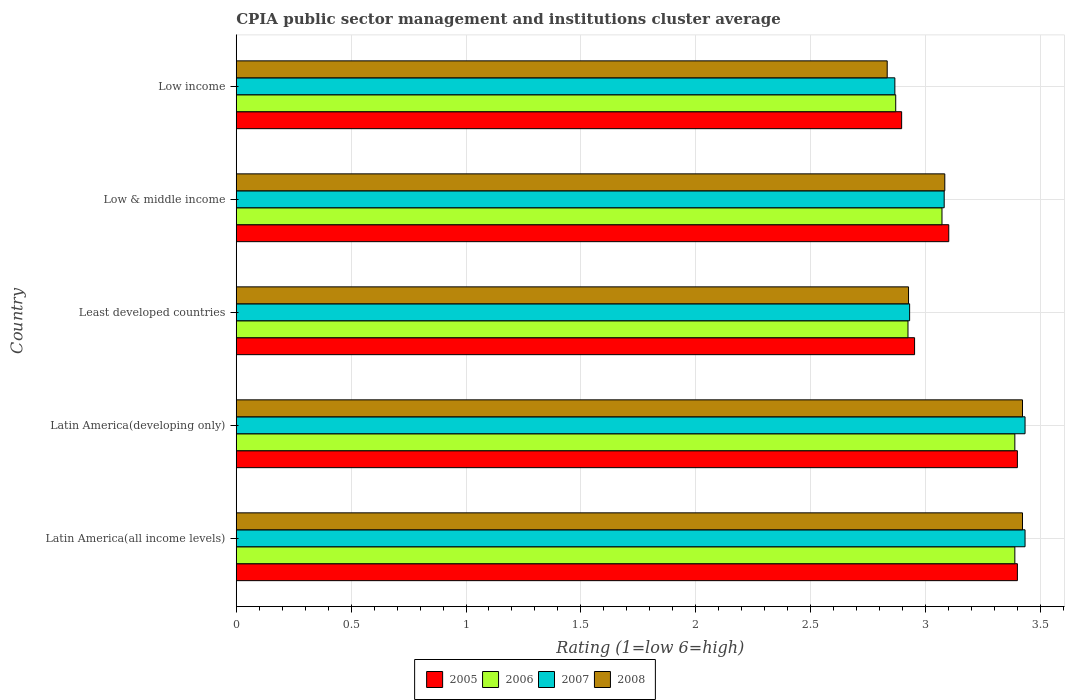How many groups of bars are there?
Offer a terse response. 5. Are the number of bars per tick equal to the number of legend labels?
Make the answer very short. Yes. How many bars are there on the 5th tick from the top?
Provide a succinct answer. 4. How many bars are there on the 5th tick from the bottom?
Offer a very short reply. 4. What is the label of the 1st group of bars from the top?
Offer a terse response. Low income. What is the CPIA rating in 2006 in Latin America(developing only)?
Provide a succinct answer. 3.39. Across all countries, what is the maximum CPIA rating in 2007?
Give a very brief answer. 3.43. Across all countries, what is the minimum CPIA rating in 2007?
Make the answer very short. 2.87. In which country was the CPIA rating in 2006 maximum?
Your response must be concise. Latin America(all income levels). What is the total CPIA rating in 2005 in the graph?
Give a very brief answer. 15.75. What is the difference between the CPIA rating in 2008 in Least developed countries and that in Low & middle income?
Your answer should be very brief. -0.16. What is the difference between the CPIA rating in 2006 in Latin America(all income levels) and the CPIA rating in 2005 in Low income?
Keep it short and to the point. 0.49. What is the average CPIA rating in 2006 per country?
Make the answer very short. 3.13. What is the difference between the CPIA rating in 2007 and CPIA rating in 2005 in Latin America(developing only)?
Provide a succinct answer. 0.03. In how many countries, is the CPIA rating in 2005 greater than 0.2 ?
Keep it short and to the point. 5. What is the ratio of the CPIA rating in 2006 in Latin America(developing only) to that in Least developed countries?
Provide a short and direct response. 1.16. Is the CPIA rating in 2005 in Latin America(all income levels) less than that in Latin America(developing only)?
Keep it short and to the point. No. Is the difference between the CPIA rating in 2007 in Latin America(developing only) and Low & middle income greater than the difference between the CPIA rating in 2005 in Latin America(developing only) and Low & middle income?
Offer a very short reply. Yes. What is the difference between the highest and the second highest CPIA rating in 2005?
Your response must be concise. 0. What is the difference between the highest and the lowest CPIA rating in 2006?
Provide a succinct answer. 0.52. In how many countries, is the CPIA rating in 2005 greater than the average CPIA rating in 2005 taken over all countries?
Provide a succinct answer. 2. Is it the case that in every country, the sum of the CPIA rating in 2006 and CPIA rating in 2008 is greater than the sum of CPIA rating in 2005 and CPIA rating in 2007?
Your answer should be very brief. No. Is it the case that in every country, the sum of the CPIA rating in 2008 and CPIA rating in 2006 is greater than the CPIA rating in 2005?
Provide a short and direct response. Yes. How many bars are there?
Offer a very short reply. 20. How many countries are there in the graph?
Your response must be concise. 5. What is the difference between two consecutive major ticks on the X-axis?
Your answer should be compact. 0.5. Are the values on the major ticks of X-axis written in scientific E-notation?
Ensure brevity in your answer.  No. Does the graph contain any zero values?
Offer a very short reply. No. Does the graph contain grids?
Your answer should be very brief. Yes. How are the legend labels stacked?
Your answer should be very brief. Horizontal. What is the title of the graph?
Your answer should be very brief. CPIA public sector management and institutions cluster average. Does "1965" appear as one of the legend labels in the graph?
Your answer should be compact. No. What is the label or title of the X-axis?
Your answer should be compact. Rating (1=low 6=high). What is the Rating (1=low 6=high) in 2006 in Latin America(all income levels)?
Provide a short and direct response. 3.39. What is the Rating (1=low 6=high) of 2007 in Latin America(all income levels)?
Your answer should be very brief. 3.43. What is the Rating (1=low 6=high) of 2008 in Latin America(all income levels)?
Your answer should be very brief. 3.42. What is the Rating (1=low 6=high) of 2005 in Latin America(developing only)?
Your answer should be compact. 3.4. What is the Rating (1=low 6=high) of 2006 in Latin America(developing only)?
Provide a short and direct response. 3.39. What is the Rating (1=low 6=high) of 2007 in Latin America(developing only)?
Offer a terse response. 3.43. What is the Rating (1=low 6=high) in 2008 in Latin America(developing only)?
Your answer should be very brief. 3.42. What is the Rating (1=low 6=high) of 2005 in Least developed countries?
Provide a succinct answer. 2.95. What is the Rating (1=low 6=high) of 2006 in Least developed countries?
Your answer should be compact. 2.92. What is the Rating (1=low 6=high) of 2007 in Least developed countries?
Your answer should be compact. 2.93. What is the Rating (1=low 6=high) of 2008 in Least developed countries?
Offer a terse response. 2.93. What is the Rating (1=low 6=high) of 2005 in Low & middle income?
Give a very brief answer. 3.1. What is the Rating (1=low 6=high) of 2006 in Low & middle income?
Make the answer very short. 3.07. What is the Rating (1=low 6=high) in 2007 in Low & middle income?
Ensure brevity in your answer.  3.08. What is the Rating (1=low 6=high) of 2008 in Low & middle income?
Make the answer very short. 3.08. What is the Rating (1=low 6=high) of 2005 in Low income?
Offer a terse response. 2.9. What is the Rating (1=low 6=high) in 2006 in Low income?
Ensure brevity in your answer.  2.87. What is the Rating (1=low 6=high) in 2007 in Low income?
Provide a succinct answer. 2.87. What is the Rating (1=low 6=high) of 2008 in Low income?
Offer a very short reply. 2.83. Across all countries, what is the maximum Rating (1=low 6=high) in 2006?
Your answer should be compact. 3.39. Across all countries, what is the maximum Rating (1=low 6=high) of 2007?
Make the answer very short. 3.43. Across all countries, what is the maximum Rating (1=low 6=high) in 2008?
Your answer should be compact. 3.42. Across all countries, what is the minimum Rating (1=low 6=high) of 2005?
Offer a very short reply. 2.9. Across all countries, what is the minimum Rating (1=low 6=high) in 2006?
Provide a succinct answer. 2.87. Across all countries, what is the minimum Rating (1=low 6=high) in 2007?
Ensure brevity in your answer.  2.87. Across all countries, what is the minimum Rating (1=low 6=high) of 2008?
Offer a terse response. 2.83. What is the total Rating (1=low 6=high) in 2005 in the graph?
Your response must be concise. 15.75. What is the total Rating (1=low 6=high) in 2006 in the graph?
Offer a very short reply. 15.64. What is the total Rating (1=low 6=high) of 2007 in the graph?
Your response must be concise. 15.75. What is the total Rating (1=low 6=high) in 2008 in the graph?
Offer a terse response. 15.69. What is the difference between the Rating (1=low 6=high) in 2005 in Latin America(all income levels) and that in Latin America(developing only)?
Keep it short and to the point. 0. What is the difference between the Rating (1=low 6=high) in 2006 in Latin America(all income levels) and that in Latin America(developing only)?
Your answer should be very brief. 0. What is the difference between the Rating (1=low 6=high) of 2007 in Latin America(all income levels) and that in Latin America(developing only)?
Your answer should be compact. 0. What is the difference between the Rating (1=low 6=high) of 2008 in Latin America(all income levels) and that in Latin America(developing only)?
Your response must be concise. 0. What is the difference between the Rating (1=low 6=high) of 2005 in Latin America(all income levels) and that in Least developed countries?
Keep it short and to the point. 0.45. What is the difference between the Rating (1=low 6=high) of 2006 in Latin America(all income levels) and that in Least developed countries?
Your response must be concise. 0.47. What is the difference between the Rating (1=low 6=high) in 2007 in Latin America(all income levels) and that in Least developed countries?
Make the answer very short. 0.5. What is the difference between the Rating (1=low 6=high) in 2008 in Latin America(all income levels) and that in Least developed countries?
Give a very brief answer. 0.5. What is the difference between the Rating (1=low 6=high) of 2005 in Latin America(all income levels) and that in Low & middle income?
Offer a very short reply. 0.3. What is the difference between the Rating (1=low 6=high) of 2006 in Latin America(all income levels) and that in Low & middle income?
Provide a short and direct response. 0.32. What is the difference between the Rating (1=low 6=high) of 2007 in Latin America(all income levels) and that in Low & middle income?
Your answer should be compact. 0.35. What is the difference between the Rating (1=low 6=high) of 2008 in Latin America(all income levels) and that in Low & middle income?
Your response must be concise. 0.34. What is the difference between the Rating (1=low 6=high) in 2005 in Latin America(all income levels) and that in Low income?
Make the answer very short. 0.5. What is the difference between the Rating (1=low 6=high) in 2006 in Latin America(all income levels) and that in Low income?
Offer a very short reply. 0.52. What is the difference between the Rating (1=low 6=high) of 2007 in Latin America(all income levels) and that in Low income?
Offer a terse response. 0.57. What is the difference between the Rating (1=low 6=high) in 2008 in Latin America(all income levels) and that in Low income?
Ensure brevity in your answer.  0.59. What is the difference between the Rating (1=low 6=high) of 2005 in Latin America(developing only) and that in Least developed countries?
Your answer should be very brief. 0.45. What is the difference between the Rating (1=low 6=high) of 2006 in Latin America(developing only) and that in Least developed countries?
Your response must be concise. 0.47. What is the difference between the Rating (1=low 6=high) of 2007 in Latin America(developing only) and that in Least developed countries?
Make the answer very short. 0.5. What is the difference between the Rating (1=low 6=high) in 2008 in Latin America(developing only) and that in Least developed countries?
Keep it short and to the point. 0.5. What is the difference between the Rating (1=low 6=high) of 2005 in Latin America(developing only) and that in Low & middle income?
Your answer should be compact. 0.3. What is the difference between the Rating (1=low 6=high) of 2006 in Latin America(developing only) and that in Low & middle income?
Give a very brief answer. 0.32. What is the difference between the Rating (1=low 6=high) of 2007 in Latin America(developing only) and that in Low & middle income?
Keep it short and to the point. 0.35. What is the difference between the Rating (1=low 6=high) in 2008 in Latin America(developing only) and that in Low & middle income?
Your answer should be very brief. 0.34. What is the difference between the Rating (1=low 6=high) of 2005 in Latin America(developing only) and that in Low income?
Provide a short and direct response. 0.5. What is the difference between the Rating (1=low 6=high) in 2006 in Latin America(developing only) and that in Low income?
Offer a terse response. 0.52. What is the difference between the Rating (1=low 6=high) of 2007 in Latin America(developing only) and that in Low income?
Provide a succinct answer. 0.57. What is the difference between the Rating (1=low 6=high) of 2008 in Latin America(developing only) and that in Low income?
Keep it short and to the point. 0.59. What is the difference between the Rating (1=low 6=high) of 2005 in Least developed countries and that in Low & middle income?
Offer a terse response. -0.15. What is the difference between the Rating (1=low 6=high) of 2006 in Least developed countries and that in Low & middle income?
Your answer should be very brief. -0.15. What is the difference between the Rating (1=low 6=high) of 2007 in Least developed countries and that in Low & middle income?
Give a very brief answer. -0.15. What is the difference between the Rating (1=low 6=high) in 2008 in Least developed countries and that in Low & middle income?
Provide a succinct answer. -0.16. What is the difference between the Rating (1=low 6=high) of 2005 in Least developed countries and that in Low income?
Make the answer very short. 0.06. What is the difference between the Rating (1=low 6=high) in 2006 in Least developed countries and that in Low income?
Ensure brevity in your answer.  0.05. What is the difference between the Rating (1=low 6=high) of 2007 in Least developed countries and that in Low income?
Provide a short and direct response. 0.06. What is the difference between the Rating (1=low 6=high) in 2008 in Least developed countries and that in Low income?
Your response must be concise. 0.09. What is the difference between the Rating (1=low 6=high) of 2005 in Low & middle income and that in Low income?
Offer a terse response. 0.21. What is the difference between the Rating (1=low 6=high) of 2006 in Low & middle income and that in Low income?
Offer a terse response. 0.2. What is the difference between the Rating (1=low 6=high) of 2007 in Low & middle income and that in Low income?
Offer a terse response. 0.21. What is the difference between the Rating (1=low 6=high) of 2008 in Low & middle income and that in Low income?
Give a very brief answer. 0.25. What is the difference between the Rating (1=low 6=high) in 2005 in Latin America(all income levels) and the Rating (1=low 6=high) in 2006 in Latin America(developing only)?
Offer a terse response. 0.01. What is the difference between the Rating (1=low 6=high) in 2005 in Latin America(all income levels) and the Rating (1=low 6=high) in 2007 in Latin America(developing only)?
Your response must be concise. -0.03. What is the difference between the Rating (1=low 6=high) in 2005 in Latin America(all income levels) and the Rating (1=low 6=high) in 2008 in Latin America(developing only)?
Provide a succinct answer. -0.02. What is the difference between the Rating (1=low 6=high) in 2006 in Latin America(all income levels) and the Rating (1=low 6=high) in 2007 in Latin America(developing only)?
Provide a succinct answer. -0.04. What is the difference between the Rating (1=low 6=high) in 2006 in Latin America(all income levels) and the Rating (1=low 6=high) in 2008 in Latin America(developing only)?
Keep it short and to the point. -0.03. What is the difference between the Rating (1=low 6=high) of 2007 in Latin America(all income levels) and the Rating (1=low 6=high) of 2008 in Latin America(developing only)?
Ensure brevity in your answer.  0.01. What is the difference between the Rating (1=low 6=high) in 2005 in Latin America(all income levels) and the Rating (1=low 6=high) in 2006 in Least developed countries?
Ensure brevity in your answer.  0.48. What is the difference between the Rating (1=low 6=high) of 2005 in Latin America(all income levels) and the Rating (1=low 6=high) of 2007 in Least developed countries?
Ensure brevity in your answer.  0.47. What is the difference between the Rating (1=low 6=high) of 2005 in Latin America(all income levels) and the Rating (1=low 6=high) of 2008 in Least developed countries?
Your response must be concise. 0.47. What is the difference between the Rating (1=low 6=high) in 2006 in Latin America(all income levels) and the Rating (1=low 6=high) in 2007 in Least developed countries?
Provide a short and direct response. 0.46. What is the difference between the Rating (1=low 6=high) of 2006 in Latin America(all income levels) and the Rating (1=low 6=high) of 2008 in Least developed countries?
Offer a very short reply. 0.46. What is the difference between the Rating (1=low 6=high) of 2007 in Latin America(all income levels) and the Rating (1=low 6=high) of 2008 in Least developed countries?
Offer a very short reply. 0.51. What is the difference between the Rating (1=low 6=high) in 2005 in Latin America(all income levels) and the Rating (1=low 6=high) in 2006 in Low & middle income?
Your response must be concise. 0.33. What is the difference between the Rating (1=low 6=high) of 2005 in Latin America(all income levels) and the Rating (1=low 6=high) of 2007 in Low & middle income?
Offer a terse response. 0.32. What is the difference between the Rating (1=low 6=high) of 2005 in Latin America(all income levels) and the Rating (1=low 6=high) of 2008 in Low & middle income?
Ensure brevity in your answer.  0.32. What is the difference between the Rating (1=low 6=high) in 2006 in Latin America(all income levels) and the Rating (1=low 6=high) in 2007 in Low & middle income?
Keep it short and to the point. 0.31. What is the difference between the Rating (1=low 6=high) of 2006 in Latin America(all income levels) and the Rating (1=low 6=high) of 2008 in Low & middle income?
Provide a succinct answer. 0.3. What is the difference between the Rating (1=low 6=high) in 2007 in Latin America(all income levels) and the Rating (1=low 6=high) in 2008 in Low & middle income?
Your answer should be compact. 0.35. What is the difference between the Rating (1=low 6=high) in 2005 in Latin America(all income levels) and the Rating (1=low 6=high) in 2006 in Low income?
Your answer should be very brief. 0.53. What is the difference between the Rating (1=low 6=high) in 2005 in Latin America(all income levels) and the Rating (1=low 6=high) in 2007 in Low income?
Your answer should be compact. 0.53. What is the difference between the Rating (1=low 6=high) of 2005 in Latin America(all income levels) and the Rating (1=low 6=high) of 2008 in Low income?
Provide a short and direct response. 0.57. What is the difference between the Rating (1=low 6=high) of 2006 in Latin America(all income levels) and the Rating (1=low 6=high) of 2007 in Low income?
Offer a very short reply. 0.52. What is the difference between the Rating (1=low 6=high) of 2006 in Latin America(all income levels) and the Rating (1=low 6=high) of 2008 in Low income?
Provide a succinct answer. 0.56. What is the difference between the Rating (1=low 6=high) of 2005 in Latin America(developing only) and the Rating (1=low 6=high) of 2006 in Least developed countries?
Your answer should be compact. 0.48. What is the difference between the Rating (1=low 6=high) of 2005 in Latin America(developing only) and the Rating (1=low 6=high) of 2007 in Least developed countries?
Offer a terse response. 0.47. What is the difference between the Rating (1=low 6=high) of 2005 in Latin America(developing only) and the Rating (1=low 6=high) of 2008 in Least developed countries?
Make the answer very short. 0.47. What is the difference between the Rating (1=low 6=high) of 2006 in Latin America(developing only) and the Rating (1=low 6=high) of 2007 in Least developed countries?
Keep it short and to the point. 0.46. What is the difference between the Rating (1=low 6=high) of 2006 in Latin America(developing only) and the Rating (1=low 6=high) of 2008 in Least developed countries?
Ensure brevity in your answer.  0.46. What is the difference between the Rating (1=low 6=high) of 2007 in Latin America(developing only) and the Rating (1=low 6=high) of 2008 in Least developed countries?
Provide a short and direct response. 0.51. What is the difference between the Rating (1=low 6=high) of 2005 in Latin America(developing only) and the Rating (1=low 6=high) of 2006 in Low & middle income?
Make the answer very short. 0.33. What is the difference between the Rating (1=low 6=high) of 2005 in Latin America(developing only) and the Rating (1=low 6=high) of 2007 in Low & middle income?
Your answer should be compact. 0.32. What is the difference between the Rating (1=low 6=high) of 2005 in Latin America(developing only) and the Rating (1=low 6=high) of 2008 in Low & middle income?
Keep it short and to the point. 0.32. What is the difference between the Rating (1=low 6=high) of 2006 in Latin America(developing only) and the Rating (1=low 6=high) of 2007 in Low & middle income?
Make the answer very short. 0.31. What is the difference between the Rating (1=low 6=high) in 2006 in Latin America(developing only) and the Rating (1=low 6=high) in 2008 in Low & middle income?
Provide a succinct answer. 0.3. What is the difference between the Rating (1=low 6=high) of 2007 in Latin America(developing only) and the Rating (1=low 6=high) of 2008 in Low & middle income?
Your response must be concise. 0.35. What is the difference between the Rating (1=low 6=high) of 2005 in Latin America(developing only) and the Rating (1=low 6=high) of 2006 in Low income?
Your answer should be very brief. 0.53. What is the difference between the Rating (1=low 6=high) of 2005 in Latin America(developing only) and the Rating (1=low 6=high) of 2007 in Low income?
Offer a terse response. 0.53. What is the difference between the Rating (1=low 6=high) in 2005 in Latin America(developing only) and the Rating (1=low 6=high) in 2008 in Low income?
Ensure brevity in your answer.  0.57. What is the difference between the Rating (1=low 6=high) of 2006 in Latin America(developing only) and the Rating (1=low 6=high) of 2007 in Low income?
Give a very brief answer. 0.52. What is the difference between the Rating (1=low 6=high) in 2006 in Latin America(developing only) and the Rating (1=low 6=high) in 2008 in Low income?
Keep it short and to the point. 0.56. What is the difference between the Rating (1=low 6=high) of 2007 in Latin America(developing only) and the Rating (1=low 6=high) of 2008 in Low income?
Keep it short and to the point. 0.6. What is the difference between the Rating (1=low 6=high) of 2005 in Least developed countries and the Rating (1=low 6=high) of 2006 in Low & middle income?
Provide a succinct answer. -0.12. What is the difference between the Rating (1=low 6=high) of 2005 in Least developed countries and the Rating (1=low 6=high) of 2007 in Low & middle income?
Your response must be concise. -0.13. What is the difference between the Rating (1=low 6=high) in 2005 in Least developed countries and the Rating (1=low 6=high) in 2008 in Low & middle income?
Offer a terse response. -0.13. What is the difference between the Rating (1=low 6=high) in 2006 in Least developed countries and the Rating (1=low 6=high) in 2007 in Low & middle income?
Give a very brief answer. -0.16. What is the difference between the Rating (1=low 6=high) of 2006 in Least developed countries and the Rating (1=low 6=high) of 2008 in Low & middle income?
Keep it short and to the point. -0.16. What is the difference between the Rating (1=low 6=high) of 2007 in Least developed countries and the Rating (1=low 6=high) of 2008 in Low & middle income?
Your answer should be compact. -0.15. What is the difference between the Rating (1=low 6=high) of 2005 in Least developed countries and the Rating (1=low 6=high) of 2006 in Low income?
Keep it short and to the point. 0.08. What is the difference between the Rating (1=low 6=high) of 2005 in Least developed countries and the Rating (1=low 6=high) of 2007 in Low income?
Provide a short and direct response. 0.09. What is the difference between the Rating (1=low 6=high) of 2005 in Least developed countries and the Rating (1=low 6=high) of 2008 in Low income?
Your response must be concise. 0.12. What is the difference between the Rating (1=low 6=high) in 2006 in Least developed countries and the Rating (1=low 6=high) in 2007 in Low income?
Your answer should be compact. 0.06. What is the difference between the Rating (1=low 6=high) in 2006 in Least developed countries and the Rating (1=low 6=high) in 2008 in Low income?
Offer a terse response. 0.09. What is the difference between the Rating (1=low 6=high) in 2007 in Least developed countries and the Rating (1=low 6=high) in 2008 in Low income?
Your answer should be compact. 0.1. What is the difference between the Rating (1=low 6=high) of 2005 in Low & middle income and the Rating (1=low 6=high) of 2006 in Low income?
Provide a short and direct response. 0.23. What is the difference between the Rating (1=low 6=high) in 2005 in Low & middle income and the Rating (1=low 6=high) in 2007 in Low income?
Your response must be concise. 0.23. What is the difference between the Rating (1=low 6=high) of 2005 in Low & middle income and the Rating (1=low 6=high) of 2008 in Low income?
Your answer should be very brief. 0.27. What is the difference between the Rating (1=low 6=high) of 2006 in Low & middle income and the Rating (1=low 6=high) of 2007 in Low income?
Your response must be concise. 0.21. What is the difference between the Rating (1=low 6=high) in 2006 in Low & middle income and the Rating (1=low 6=high) in 2008 in Low income?
Your response must be concise. 0.24. What is the difference between the Rating (1=low 6=high) in 2007 in Low & middle income and the Rating (1=low 6=high) in 2008 in Low income?
Your answer should be compact. 0.25. What is the average Rating (1=low 6=high) in 2005 per country?
Your answer should be compact. 3.15. What is the average Rating (1=low 6=high) in 2006 per country?
Provide a succinct answer. 3.13. What is the average Rating (1=low 6=high) in 2007 per country?
Provide a short and direct response. 3.15. What is the average Rating (1=low 6=high) of 2008 per country?
Your response must be concise. 3.14. What is the difference between the Rating (1=low 6=high) in 2005 and Rating (1=low 6=high) in 2006 in Latin America(all income levels)?
Offer a terse response. 0.01. What is the difference between the Rating (1=low 6=high) of 2005 and Rating (1=low 6=high) of 2007 in Latin America(all income levels)?
Give a very brief answer. -0.03. What is the difference between the Rating (1=low 6=high) in 2005 and Rating (1=low 6=high) in 2008 in Latin America(all income levels)?
Your answer should be compact. -0.02. What is the difference between the Rating (1=low 6=high) in 2006 and Rating (1=low 6=high) in 2007 in Latin America(all income levels)?
Your answer should be very brief. -0.04. What is the difference between the Rating (1=low 6=high) of 2006 and Rating (1=low 6=high) of 2008 in Latin America(all income levels)?
Ensure brevity in your answer.  -0.03. What is the difference between the Rating (1=low 6=high) in 2007 and Rating (1=low 6=high) in 2008 in Latin America(all income levels)?
Ensure brevity in your answer.  0.01. What is the difference between the Rating (1=low 6=high) of 2005 and Rating (1=low 6=high) of 2006 in Latin America(developing only)?
Your answer should be very brief. 0.01. What is the difference between the Rating (1=low 6=high) of 2005 and Rating (1=low 6=high) of 2007 in Latin America(developing only)?
Ensure brevity in your answer.  -0.03. What is the difference between the Rating (1=low 6=high) in 2005 and Rating (1=low 6=high) in 2008 in Latin America(developing only)?
Give a very brief answer. -0.02. What is the difference between the Rating (1=low 6=high) of 2006 and Rating (1=low 6=high) of 2007 in Latin America(developing only)?
Give a very brief answer. -0.04. What is the difference between the Rating (1=low 6=high) of 2006 and Rating (1=low 6=high) of 2008 in Latin America(developing only)?
Offer a very short reply. -0.03. What is the difference between the Rating (1=low 6=high) of 2007 and Rating (1=low 6=high) of 2008 in Latin America(developing only)?
Provide a short and direct response. 0.01. What is the difference between the Rating (1=low 6=high) in 2005 and Rating (1=low 6=high) in 2006 in Least developed countries?
Ensure brevity in your answer.  0.03. What is the difference between the Rating (1=low 6=high) in 2005 and Rating (1=low 6=high) in 2007 in Least developed countries?
Offer a very short reply. 0.02. What is the difference between the Rating (1=low 6=high) in 2005 and Rating (1=low 6=high) in 2008 in Least developed countries?
Offer a very short reply. 0.03. What is the difference between the Rating (1=low 6=high) of 2006 and Rating (1=low 6=high) of 2007 in Least developed countries?
Give a very brief answer. -0.01. What is the difference between the Rating (1=low 6=high) in 2006 and Rating (1=low 6=high) in 2008 in Least developed countries?
Offer a very short reply. -0. What is the difference between the Rating (1=low 6=high) of 2007 and Rating (1=low 6=high) of 2008 in Least developed countries?
Offer a terse response. 0. What is the difference between the Rating (1=low 6=high) in 2005 and Rating (1=low 6=high) in 2006 in Low & middle income?
Your answer should be compact. 0.03. What is the difference between the Rating (1=low 6=high) of 2005 and Rating (1=low 6=high) of 2008 in Low & middle income?
Give a very brief answer. 0.02. What is the difference between the Rating (1=low 6=high) in 2006 and Rating (1=low 6=high) in 2007 in Low & middle income?
Offer a terse response. -0.01. What is the difference between the Rating (1=low 6=high) of 2006 and Rating (1=low 6=high) of 2008 in Low & middle income?
Give a very brief answer. -0.01. What is the difference between the Rating (1=low 6=high) of 2007 and Rating (1=low 6=high) of 2008 in Low & middle income?
Offer a terse response. -0. What is the difference between the Rating (1=low 6=high) of 2005 and Rating (1=low 6=high) of 2006 in Low income?
Offer a terse response. 0.03. What is the difference between the Rating (1=low 6=high) of 2005 and Rating (1=low 6=high) of 2007 in Low income?
Provide a short and direct response. 0.03. What is the difference between the Rating (1=low 6=high) of 2005 and Rating (1=low 6=high) of 2008 in Low income?
Provide a short and direct response. 0.06. What is the difference between the Rating (1=low 6=high) in 2006 and Rating (1=low 6=high) in 2007 in Low income?
Provide a succinct answer. 0. What is the difference between the Rating (1=low 6=high) in 2006 and Rating (1=low 6=high) in 2008 in Low income?
Provide a short and direct response. 0.04. What is the ratio of the Rating (1=low 6=high) of 2007 in Latin America(all income levels) to that in Latin America(developing only)?
Provide a succinct answer. 1. What is the ratio of the Rating (1=low 6=high) of 2005 in Latin America(all income levels) to that in Least developed countries?
Provide a short and direct response. 1.15. What is the ratio of the Rating (1=low 6=high) of 2006 in Latin America(all income levels) to that in Least developed countries?
Your answer should be compact. 1.16. What is the ratio of the Rating (1=low 6=high) of 2007 in Latin America(all income levels) to that in Least developed countries?
Keep it short and to the point. 1.17. What is the ratio of the Rating (1=low 6=high) in 2008 in Latin America(all income levels) to that in Least developed countries?
Your answer should be compact. 1.17. What is the ratio of the Rating (1=low 6=high) in 2005 in Latin America(all income levels) to that in Low & middle income?
Provide a short and direct response. 1.1. What is the ratio of the Rating (1=low 6=high) of 2006 in Latin America(all income levels) to that in Low & middle income?
Make the answer very short. 1.1. What is the ratio of the Rating (1=low 6=high) in 2007 in Latin America(all income levels) to that in Low & middle income?
Make the answer very short. 1.11. What is the ratio of the Rating (1=low 6=high) of 2008 in Latin America(all income levels) to that in Low & middle income?
Your answer should be compact. 1.11. What is the ratio of the Rating (1=low 6=high) of 2005 in Latin America(all income levels) to that in Low income?
Your answer should be very brief. 1.17. What is the ratio of the Rating (1=low 6=high) of 2006 in Latin America(all income levels) to that in Low income?
Provide a succinct answer. 1.18. What is the ratio of the Rating (1=low 6=high) in 2007 in Latin America(all income levels) to that in Low income?
Your answer should be compact. 1.2. What is the ratio of the Rating (1=low 6=high) of 2008 in Latin America(all income levels) to that in Low income?
Make the answer very short. 1.21. What is the ratio of the Rating (1=low 6=high) of 2005 in Latin America(developing only) to that in Least developed countries?
Your answer should be compact. 1.15. What is the ratio of the Rating (1=low 6=high) of 2006 in Latin America(developing only) to that in Least developed countries?
Make the answer very short. 1.16. What is the ratio of the Rating (1=low 6=high) of 2007 in Latin America(developing only) to that in Least developed countries?
Provide a succinct answer. 1.17. What is the ratio of the Rating (1=low 6=high) of 2008 in Latin America(developing only) to that in Least developed countries?
Offer a terse response. 1.17. What is the ratio of the Rating (1=low 6=high) in 2005 in Latin America(developing only) to that in Low & middle income?
Provide a succinct answer. 1.1. What is the ratio of the Rating (1=low 6=high) in 2006 in Latin America(developing only) to that in Low & middle income?
Make the answer very short. 1.1. What is the ratio of the Rating (1=low 6=high) of 2007 in Latin America(developing only) to that in Low & middle income?
Offer a terse response. 1.11. What is the ratio of the Rating (1=low 6=high) in 2008 in Latin America(developing only) to that in Low & middle income?
Offer a terse response. 1.11. What is the ratio of the Rating (1=low 6=high) in 2005 in Latin America(developing only) to that in Low income?
Make the answer very short. 1.17. What is the ratio of the Rating (1=low 6=high) of 2006 in Latin America(developing only) to that in Low income?
Offer a very short reply. 1.18. What is the ratio of the Rating (1=low 6=high) in 2007 in Latin America(developing only) to that in Low income?
Ensure brevity in your answer.  1.2. What is the ratio of the Rating (1=low 6=high) in 2008 in Latin America(developing only) to that in Low income?
Your response must be concise. 1.21. What is the ratio of the Rating (1=low 6=high) in 2006 in Least developed countries to that in Low & middle income?
Provide a succinct answer. 0.95. What is the ratio of the Rating (1=low 6=high) of 2007 in Least developed countries to that in Low & middle income?
Ensure brevity in your answer.  0.95. What is the ratio of the Rating (1=low 6=high) in 2008 in Least developed countries to that in Low & middle income?
Offer a very short reply. 0.95. What is the ratio of the Rating (1=low 6=high) of 2005 in Least developed countries to that in Low income?
Keep it short and to the point. 1.02. What is the ratio of the Rating (1=low 6=high) of 2006 in Least developed countries to that in Low income?
Keep it short and to the point. 1.02. What is the ratio of the Rating (1=low 6=high) of 2007 in Least developed countries to that in Low income?
Keep it short and to the point. 1.02. What is the ratio of the Rating (1=low 6=high) in 2008 in Least developed countries to that in Low income?
Keep it short and to the point. 1.03. What is the ratio of the Rating (1=low 6=high) of 2005 in Low & middle income to that in Low income?
Offer a very short reply. 1.07. What is the ratio of the Rating (1=low 6=high) in 2006 in Low & middle income to that in Low income?
Give a very brief answer. 1.07. What is the ratio of the Rating (1=low 6=high) of 2007 in Low & middle income to that in Low income?
Keep it short and to the point. 1.07. What is the ratio of the Rating (1=low 6=high) of 2008 in Low & middle income to that in Low income?
Make the answer very short. 1.09. What is the difference between the highest and the second highest Rating (1=low 6=high) in 2005?
Provide a succinct answer. 0. What is the difference between the highest and the second highest Rating (1=low 6=high) of 2007?
Make the answer very short. 0. What is the difference between the highest and the second highest Rating (1=low 6=high) of 2008?
Your answer should be compact. 0. What is the difference between the highest and the lowest Rating (1=low 6=high) in 2005?
Provide a short and direct response. 0.5. What is the difference between the highest and the lowest Rating (1=low 6=high) of 2006?
Offer a very short reply. 0.52. What is the difference between the highest and the lowest Rating (1=low 6=high) of 2007?
Your answer should be very brief. 0.57. What is the difference between the highest and the lowest Rating (1=low 6=high) in 2008?
Make the answer very short. 0.59. 